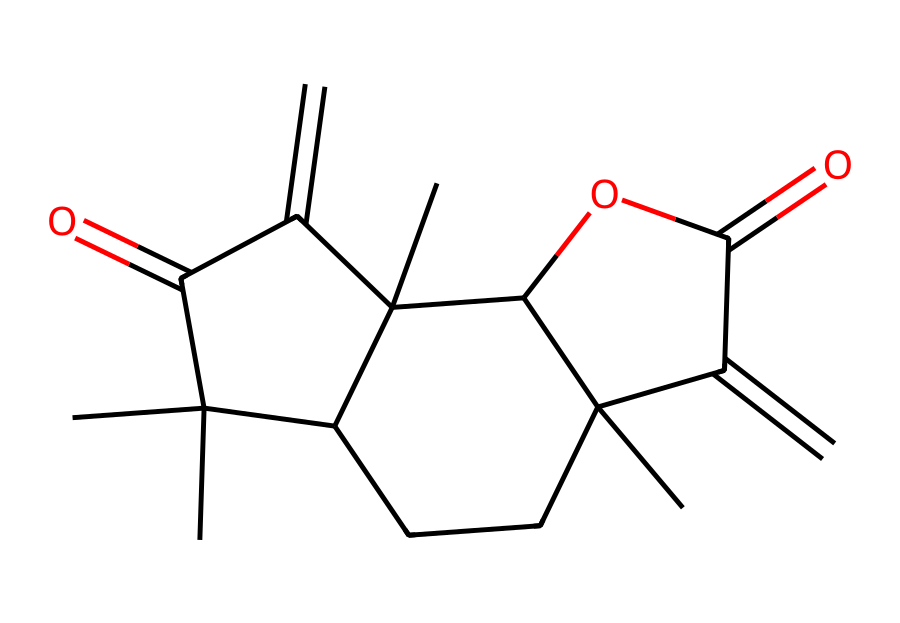What is the total number of carbon atoms in this molecule? By examining the SMILES representation, we can count the carbon atoms denoted by "C". Each "C" represents a carbon atom, and analyzing the structure shows there are 15 carbon atoms in total.
Answer: fifteen How many rings are present in this chemical structure? The structure shows two distinct cyclic portions. Each cycle in the SMILES representation suggests a ring. In total, there are 2 rings identified in this compound.
Answer: two What is the molecular formula derived from this structure? To derive the molecular formula, we count the number of carbon (C), hydrogen (H), and oxygen (O) atoms. After analyzing the SMILES, the molecular formula is determined to be C15H20O3.
Answer: C15H20O3 What functional groups can be identified in this compound? The SMILES structure contains a few key functional groups, notably the ester group (indicated by the "OC" connection) and ketones (implied by the "C=O"). Both groups contribute to the functions and characteristics of the natural pesticide.
Answer: ester and ketone How many oxygen atoms are present in this structure? In the given SMILES representation, the occurrences of "O" indicate the presence of oxygen atoms. Counting these reveals there are 3 oxygen atoms in the molecule.
Answer: three What type of pesticide is this derived compound classified as? Based on its molecular structure and the source being neem trees, this compound is categorized as a natural pesticide, primarily functioning as an insecticide.
Answer: insecticide 